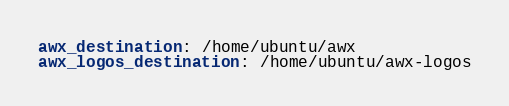<code> <loc_0><loc_0><loc_500><loc_500><_YAML_>awx_destination: /home/ubuntu/awx
awx_logos_destination: /home/ubuntu/awx-logos</code> 